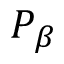<formula> <loc_0><loc_0><loc_500><loc_500>P _ { \beta }</formula> 